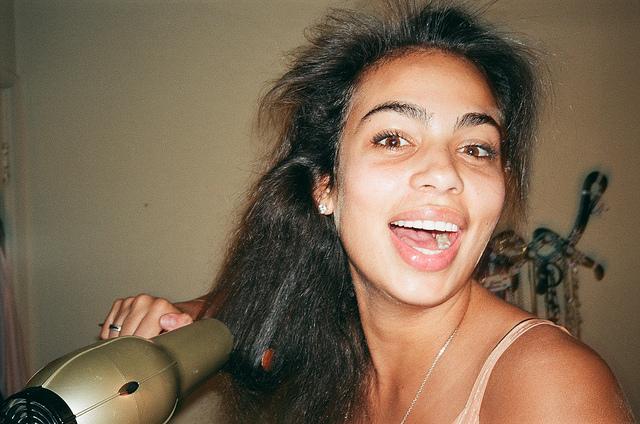Does this lady have crazy hair?
Keep it brief. Yes. Is the lady happy?
Give a very brief answer. Yes. What is she doing to her hair?
Concise answer only. Drying. 